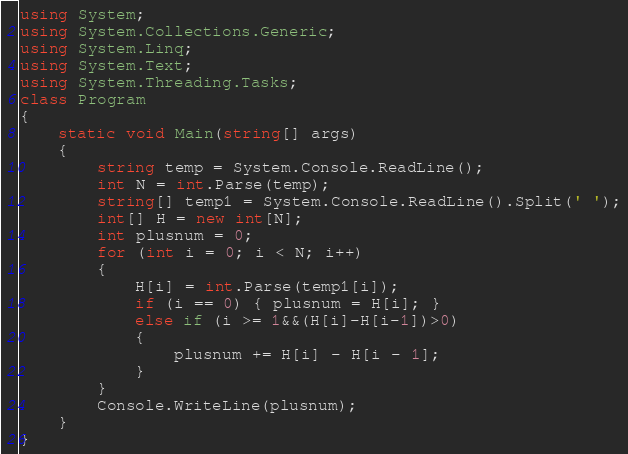Convert code to text. <code><loc_0><loc_0><loc_500><loc_500><_C#_>using System;
using System.Collections.Generic;
using System.Linq;
using System.Text;
using System.Threading.Tasks;
class Program
{
    static void Main(string[] args)
    {
        string temp = System.Console.ReadLine();
        int N = int.Parse(temp);
        string[] temp1 = System.Console.ReadLine().Split(' ');
        int[] H = new int[N];
        int plusnum = 0;
        for (int i = 0; i < N; i++)
        {
            H[i] = int.Parse(temp1[i]);
            if (i == 0) { plusnum = H[i]; }
            else if (i >= 1&&(H[i]-H[i-1])>0)
            {
                plusnum += H[i] - H[i - 1];
            }
        }
        Console.WriteLine(plusnum);
    }
}</code> 